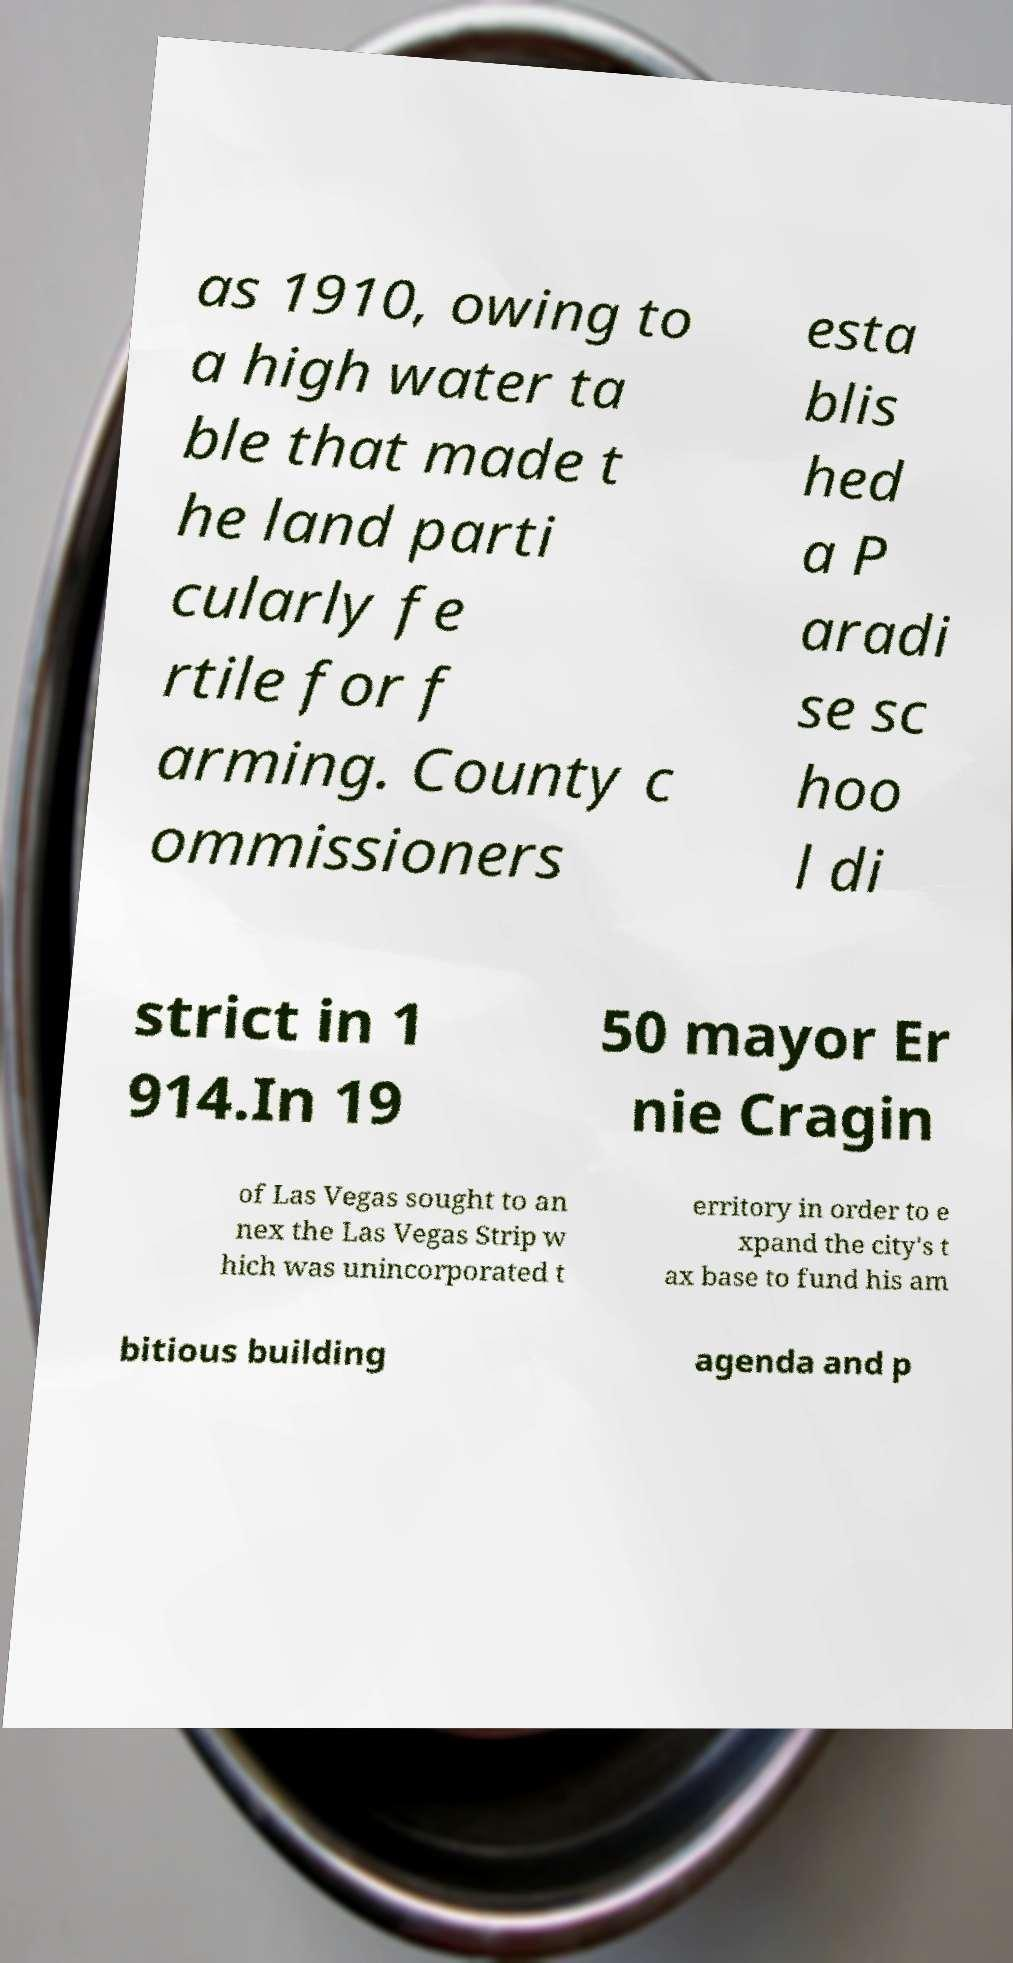Please read and relay the text visible in this image. What does it say? as 1910, owing to a high water ta ble that made t he land parti cularly fe rtile for f arming. County c ommissioners esta blis hed a P aradi se sc hoo l di strict in 1 914.In 19 50 mayor Er nie Cragin of Las Vegas sought to an nex the Las Vegas Strip w hich was unincorporated t erritory in order to e xpand the city's t ax base to fund his am bitious building agenda and p 